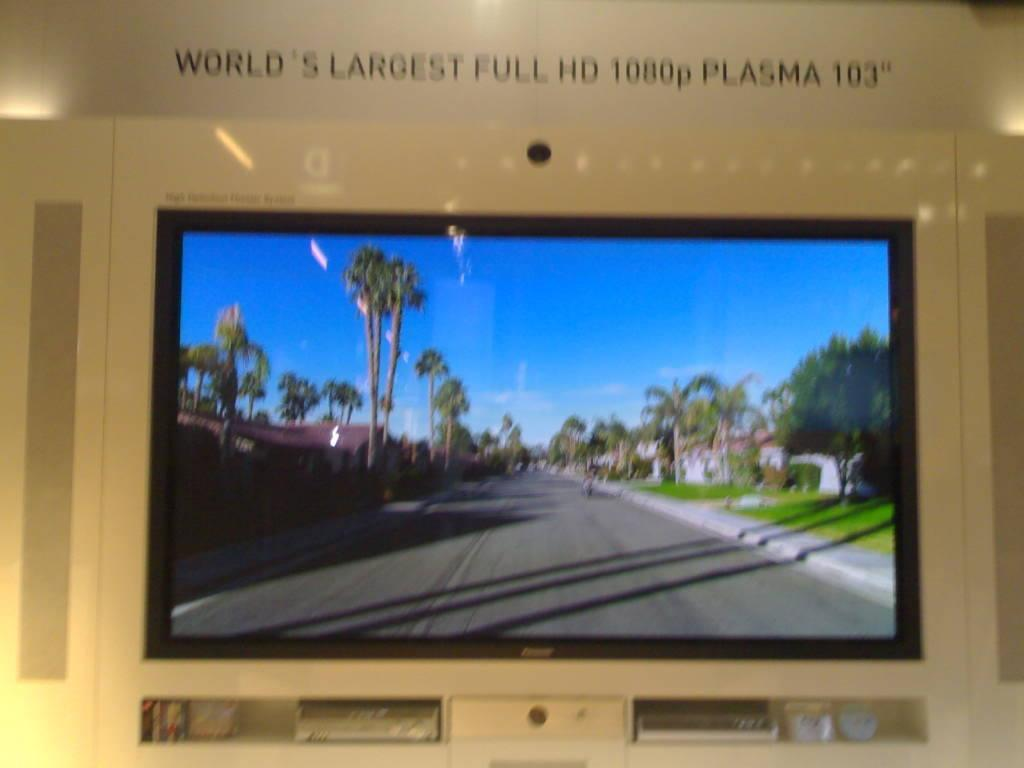Provide a one-sentence caption for the provided image. the word largest that is above a television. 